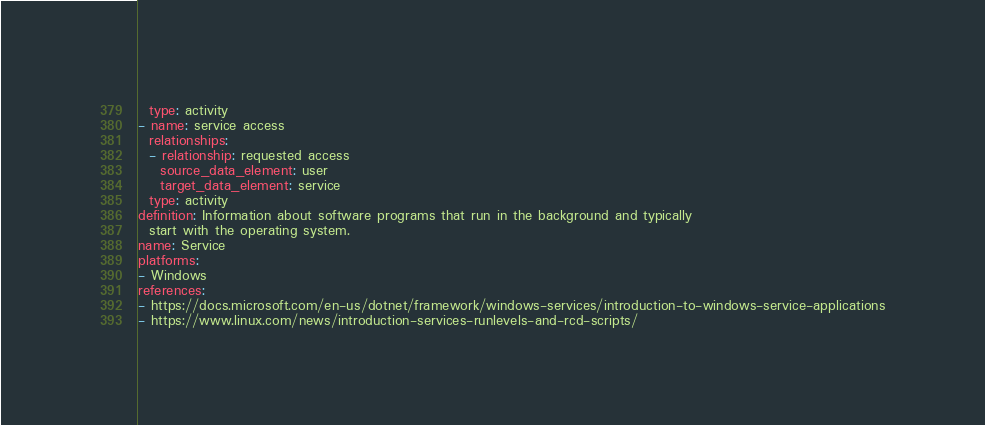Convert code to text. <code><loc_0><loc_0><loc_500><loc_500><_YAML_>  type: activity
- name: service access
  relationships:
  - relationship: requested access
    source_data_element: user
    target_data_element: service
  type: activity
definition: Information about software programs that run in the background and typically
  start with the operating system.
name: Service
platforms:
- Windows
references:
- https://docs.microsoft.com/en-us/dotnet/framework/windows-services/introduction-to-windows-service-applications
- https://www.linux.com/news/introduction-services-runlevels-and-rcd-scripts/
</code> 